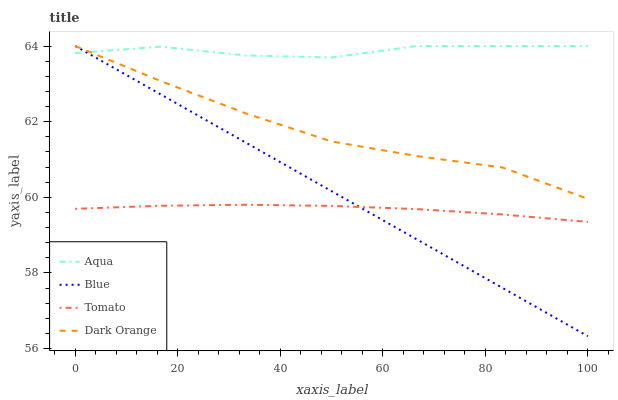Does Tomato have the minimum area under the curve?
Answer yes or no. Yes. Does Aqua have the maximum area under the curve?
Answer yes or no. Yes. Does Aqua have the minimum area under the curve?
Answer yes or no. No. Does Tomato have the maximum area under the curve?
Answer yes or no. No. Is Blue the smoothest?
Answer yes or no. Yes. Is Aqua the roughest?
Answer yes or no. Yes. Is Tomato the smoothest?
Answer yes or no. No. Is Tomato the roughest?
Answer yes or no. No. Does Blue have the lowest value?
Answer yes or no. Yes. Does Tomato have the lowest value?
Answer yes or no. No. Does Dark Orange have the highest value?
Answer yes or no. Yes. Does Tomato have the highest value?
Answer yes or no. No. Is Tomato less than Dark Orange?
Answer yes or no. Yes. Is Aqua greater than Tomato?
Answer yes or no. Yes. Does Blue intersect Dark Orange?
Answer yes or no. Yes. Is Blue less than Dark Orange?
Answer yes or no. No. Is Blue greater than Dark Orange?
Answer yes or no. No. Does Tomato intersect Dark Orange?
Answer yes or no. No. 